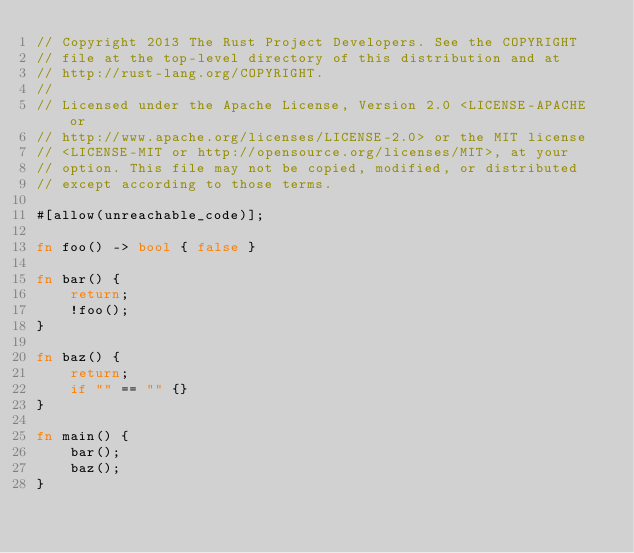Convert code to text. <code><loc_0><loc_0><loc_500><loc_500><_Rust_>// Copyright 2013 The Rust Project Developers. See the COPYRIGHT
// file at the top-level directory of this distribution and at
// http://rust-lang.org/COPYRIGHT.
//
// Licensed under the Apache License, Version 2.0 <LICENSE-APACHE or
// http://www.apache.org/licenses/LICENSE-2.0> or the MIT license
// <LICENSE-MIT or http://opensource.org/licenses/MIT>, at your
// option. This file may not be copied, modified, or distributed
// except according to those terms.

#[allow(unreachable_code)];

fn foo() -> bool { false }

fn bar() {
    return;
    !foo();
}

fn baz() {
    return;
    if "" == "" {}
}

fn main() {
    bar();
    baz();
}
</code> 